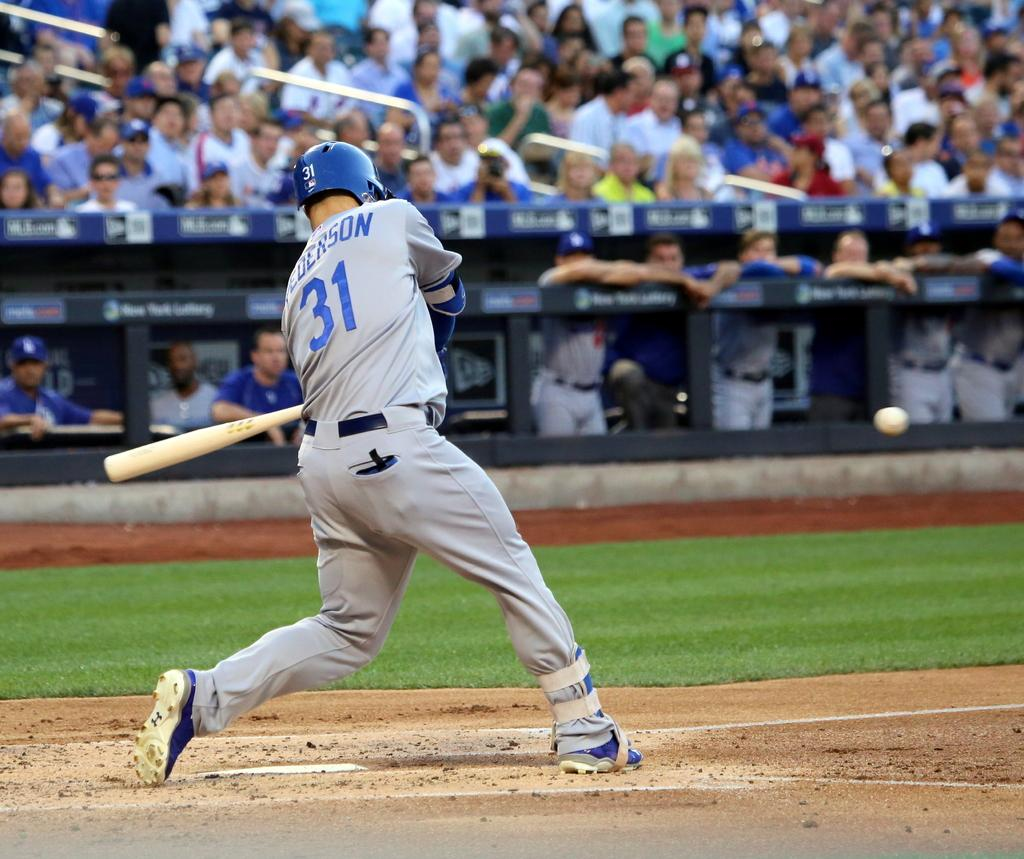<image>
Describe the image concisely. a person in a number 31 jersey hits a baseball at plate 